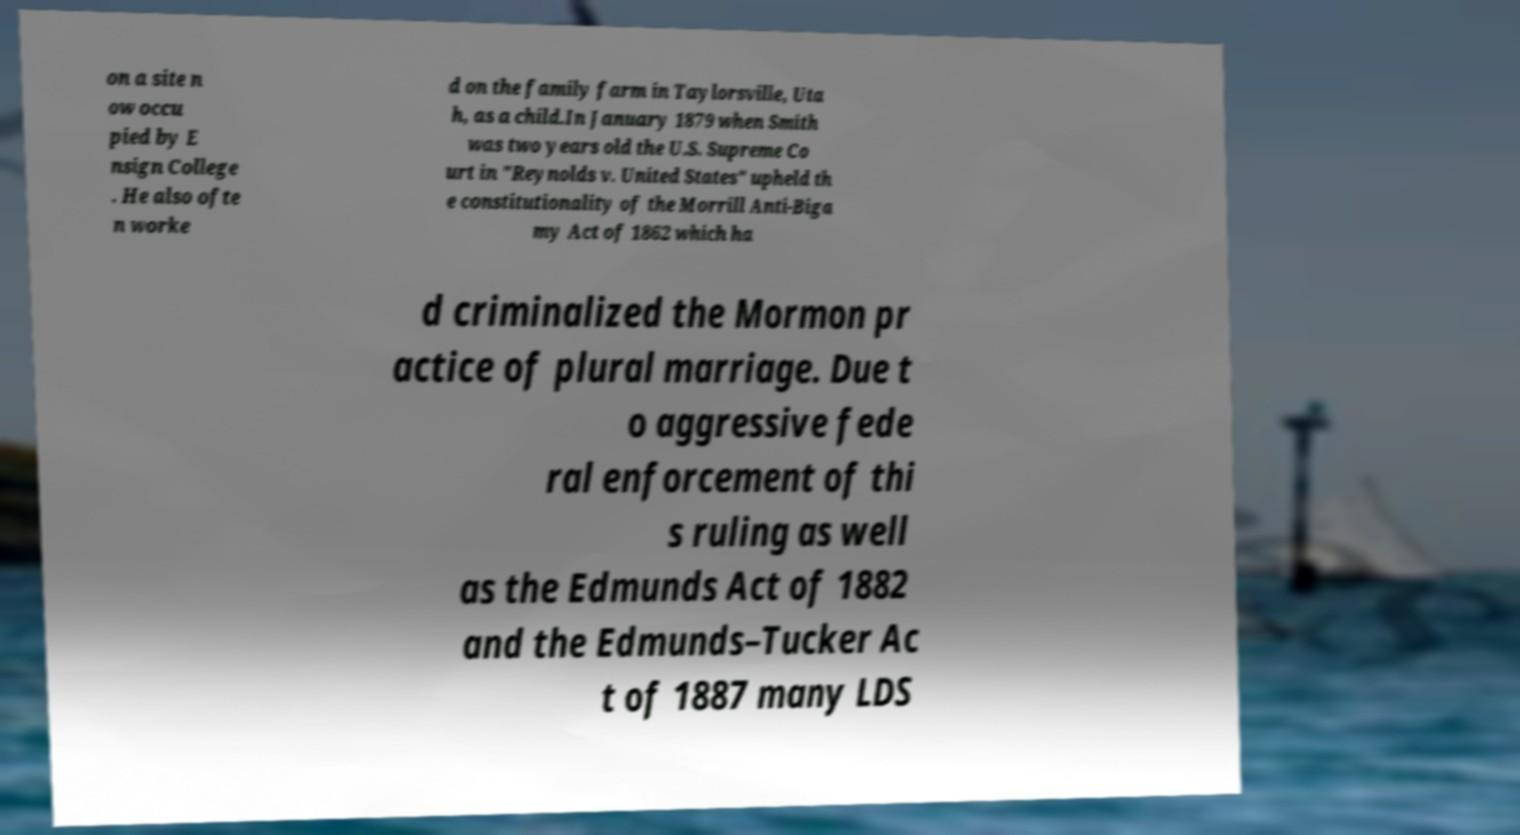Please identify and transcribe the text found in this image. on a site n ow occu pied by E nsign College . He also ofte n worke d on the family farm in Taylorsville, Uta h, as a child.In January 1879 when Smith was two years old the U.S. Supreme Co urt in "Reynolds v. United States" upheld th e constitutionality of the Morrill Anti-Biga my Act of 1862 which ha d criminalized the Mormon pr actice of plural marriage. Due t o aggressive fede ral enforcement of thi s ruling as well as the Edmunds Act of 1882 and the Edmunds–Tucker Ac t of 1887 many LDS 